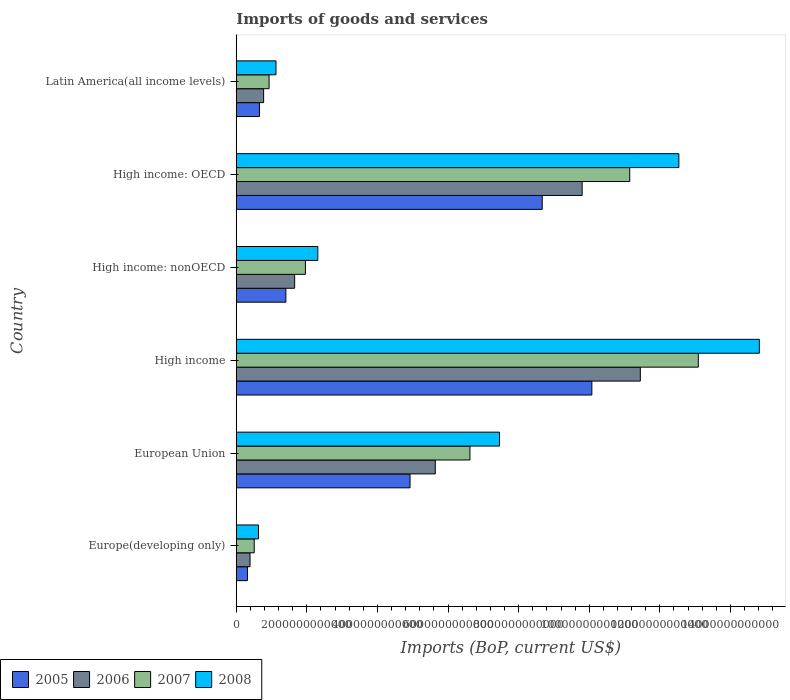How many different coloured bars are there?
Ensure brevity in your answer.  4. How many groups of bars are there?
Keep it short and to the point. 6. Are the number of bars on each tick of the Y-axis equal?
Give a very brief answer. Yes. How many bars are there on the 3rd tick from the top?
Ensure brevity in your answer.  4. What is the label of the 2nd group of bars from the top?
Provide a short and direct response. High income: OECD. In how many cases, is the number of bars for a given country not equal to the number of legend labels?
Offer a terse response. 0. What is the amount spent on imports in 2007 in Latin America(all income levels)?
Offer a terse response. 9.30e+11. Across all countries, what is the maximum amount spent on imports in 2007?
Your answer should be compact. 1.31e+13. Across all countries, what is the minimum amount spent on imports in 2008?
Offer a terse response. 6.31e+11. In which country was the amount spent on imports in 2007 minimum?
Make the answer very short. Europe(developing only). What is the total amount spent on imports in 2005 in the graph?
Give a very brief answer. 2.60e+13. What is the difference between the amount spent on imports in 2005 in Europe(developing only) and that in High income: OECD?
Offer a very short reply. -8.35e+12. What is the difference between the amount spent on imports in 2007 in High income and the amount spent on imports in 2008 in High income: nonOECD?
Provide a succinct answer. 1.08e+13. What is the average amount spent on imports in 2006 per country?
Ensure brevity in your answer.  4.95e+12. What is the difference between the amount spent on imports in 2008 and amount spent on imports in 2005 in Latin America(all income levels)?
Your answer should be compact. 4.69e+11. In how many countries, is the amount spent on imports in 2006 greater than 13600000000000 US$?
Your answer should be compact. 0. What is the ratio of the amount spent on imports in 2005 in High income to that in Latin America(all income levels)?
Offer a very short reply. 15.33. Is the amount spent on imports in 2008 in Europe(developing only) less than that in European Union?
Offer a terse response. Yes. Is the difference between the amount spent on imports in 2008 in Europe(developing only) and High income greater than the difference between the amount spent on imports in 2005 in Europe(developing only) and High income?
Keep it short and to the point. No. What is the difference between the highest and the second highest amount spent on imports in 2006?
Your response must be concise. 1.65e+12. What is the difference between the highest and the lowest amount spent on imports in 2006?
Your answer should be compact. 1.11e+13. Is the sum of the amount spent on imports in 2007 in High income and Latin America(all income levels) greater than the maximum amount spent on imports in 2005 across all countries?
Your answer should be compact. Yes. What does the 4th bar from the bottom in High income: nonOECD represents?
Ensure brevity in your answer.  2008. Is it the case that in every country, the sum of the amount spent on imports in 2006 and amount spent on imports in 2007 is greater than the amount spent on imports in 2005?
Provide a short and direct response. Yes. How many bars are there?
Offer a very short reply. 24. How many countries are there in the graph?
Your answer should be very brief. 6. What is the difference between two consecutive major ticks on the X-axis?
Your answer should be very brief. 2.00e+12. Are the values on the major ticks of X-axis written in scientific E-notation?
Offer a very short reply. No. What is the title of the graph?
Provide a short and direct response. Imports of goods and services. What is the label or title of the X-axis?
Provide a succinct answer. Imports (BoP, current US$). What is the label or title of the Y-axis?
Keep it short and to the point. Country. What is the Imports (BoP, current US$) of 2005 in Europe(developing only)?
Give a very brief answer. 3.17e+11. What is the Imports (BoP, current US$) of 2006 in Europe(developing only)?
Ensure brevity in your answer.  3.90e+11. What is the Imports (BoP, current US$) of 2007 in Europe(developing only)?
Provide a short and direct response. 5.09e+11. What is the Imports (BoP, current US$) in 2008 in Europe(developing only)?
Offer a very short reply. 6.31e+11. What is the Imports (BoP, current US$) of 2005 in European Union?
Ensure brevity in your answer.  4.92e+12. What is the Imports (BoP, current US$) in 2006 in European Union?
Provide a succinct answer. 5.64e+12. What is the Imports (BoP, current US$) in 2007 in European Union?
Provide a succinct answer. 6.62e+12. What is the Imports (BoP, current US$) in 2008 in European Union?
Ensure brevity in your answer.  7.46e+12. What is the Imports (BoP, current US$) in 2005 in High income?
Provide a succinct answer. 1.01e+13. What is the Imports (BoP, current US$) in 2006 in High income?
Your response must be concise. 1.14e+13. What is the Imports (BoP, current US$) in 2007 in High income?
Give a very brief answer. 1.31e+13. What is the Imports (BoP, current US$) of 2008 in High income?
Make the answer very short. 1.48e+13. What is the Imports (BoP, current US$) in 2005 in High income: nonOECD?
Provide a succinct answer. 1.41e+12. What is the Imports (BoP, current US$) of 2006 in High income: nonOECD?
Give a very brief answer. 1.65e+12. What is the Imports (BoP, current US$) of 2007 in High income: nonOECD?
Offer a terse response. 1.96e+12. What is the Imports (BoP, current US$) in 2008 in High income: nonOECD?
Provide a succinct answer. 2.31e+12. What is the Imports (BoP, current US$) in 2005 in High income: OECD?
Give a very brief answer. 8.67e+12. What is the Imports (BoP, current US$) in 2006 in High income: OECD?
Keep it short and to the point. 9.80e+12. What is the Imports (BoP, current US$) in 2007 in High income: OECD?
Your answer should be compact. 1.11e+13. What is the Imports (BoP, current US$) of 2008 in High income: OECD?
Your response must be concise. 1.25e+13. What is the Imports (BoP, current US$) in 2005 in Latin America(all income levels)?
Ensure brevity in your answer.  6.57e+11. What is the Imports (BoP, current US$) of 2006 in Latin America(all income levels)?
Provide a short and direct response. 7.75e+11. What is the Imports (BoP, current US$) of 2007 in Latin America(all income levels)?
Your answer should be compact. 9.30e+11. What is the Imports (BoP, current US$) in 2008 in Latin America(all income levels)?
Provide a short and direct response. 1.13e+12. Across all countries, what is the maximum Imports (BoP, current US$) of 2005?
Offer a very short reply. 1.01e+13. Across all countries, what is the maximum Imports (BoP, current US$) in 2006?
Your answer should be very brief. 1.14e+13. Across all countries, what is the maximum Imports (BoP, current US$) in 2007?
Offer a very short reply. 1.31e+13. Across all countries, what is the maximum Imports (BoP, current US$) in 2008?
Provide a short and direct response. 1.48e+13. Across all countries, what is the minimum Imports (BoP, current US$) of 2005?
Your answer should be very brief. 3.17e+11. Across all countries, what is the minimum Imports (BoP, current US$) of 2006?
Provide a short and direct response. 3.90e+11. Across all countries, what is the minimum Imports (BoP, current US$) in 2007?
Offer a very short reply. 5.09e+11. Across all countries, what is the minimum Imports (BoP, current US$) in 2008?
Provide a short and direct response. 6.31e+11. What is the total Imports (BoP, current US$) of 2005 in the graph?
Your answer should be very brief. 2.60e+13. What is the total Imports (BoP, current US$) in 2006 in the graph?
Keep it short and to the point. 2.97e+13. What is the total Imports (BoP, current US$) of 2007 in the graph?
Make the answer very short. 3.43e+13. What is the total Imports (BoP, current US$) in 2008 in the graph?
Give a very brief answer. 3.89e+13. What is the difference between the Imports (BoP, current US$) in 2005 in Europe(developing only) and that in European Union?
Your response must be concise. -4.61e+12. What is the difference between the Imports (BoP, current US$) in 2006 in Europe(developing only) and that in European Union?
Offer a terse response. -5.25e+12. What is the difference between the Imports (BoP, current US$) of 2007 in Europe(developing only) and that in European Union?
Provide a short and direct response. -6.11e+12. What is the difference between the Imports (BoP, current US$) in 2008 in Europe(developing only) and that in European Union?
Your answer should be very brief. -6.83e+12. What is the difference between the Imports (BoP, current US$) in 2005 in Europe(developing only) and that in High income?
Provide a succinct answer. -9.76e+12. What is the difference between the Imports (BoP, current US$) of 2006 in Europe(developing only) and that in High income?
Your answer should be compact. -1.11e+13. What is the difference between the Imports (BoP, current US$) in 2007 in Europe(developing only) and that in High income?
Provide a short and direct response. -1.26e+13. What is the difference between the Imports (BoP, current US$) in 2008 in Europe(developing only) and that in High income?
Your answer should be very brief. -1.42e+13. What is the difference between the Imports (BoP, current US$) in 2005 in Europe(developing only) and that in High income: nonOECD?
Offer a very short reply. -1.09e+12. What is the difference between the Imports (BoP, current US$) of 2006 in Europe(developing only) and that in High income: nonOECD?
Your answer should be very brief. -1.26e+12. What is the difference between the Imports (BoP, current US$) of 2007 in Europe(developing only) and that in High income: nonOECD?
Give a very brief answer. -1.45e+12. What is the difference between the Imports (BoP, current US$) of 2008 in Europe(developing only) and that in High income: nonOECD?
Your answer should be compact. -1.68e+12. What is the difference between the Imports (BoP, current US$) of 2005 in Europe(developing only) and that in High income: OECD?
Ensure brevity in your answer.  -8.35e+12. What is the difference between the Imports (BoP, current US$) in 2006 in Europe(developing only) and that in High income: OECD?
Keep it short and to the point. -9.41e+12. What is the difference between the Imports (BoP, current US$) in 2007 in Europe(developing only) and that in High income: OECD?
Offer a very short reply. -1.06e+13. What is the difference between the Imports (BoP, current US$) in 2008 in Europe(developing only) and that in High income: OECD?
Offer a very short reply. -1.19e+13. What is the difference between the Imports (BoP, current US$) of 2005 in Europe(developing only) and that in Latin America(all income levels)?
Offer a very short reply. -3.40e+11. What is the difference between the Imports (BoP, current US$) of 2006 in Europe(developing only) and that in Latin America(all income levels)?
Offer a terse response. -3.85e+11. What is the difference between the Imports (BoP, current US$) in 2007 in Europe(developing only) and that in Latin America(all income levels)?
Make the answer very short. -4.21e+11. What is the difference between the Imports (BoP, current US$) of 2008 in Europe(developing only) and that in Latin America(all income levels)?
Make the answer very short. -4.95e+11. What is the difference between the Imports (BoP, current US$) of 2005 in European Union and that in High income?
Your response must be concise. -5.15e+12. What is the difference between the Imports (BoP, current US$) in 2006 in European Union and that in High income?
Ensure brevity in your answer.  -5.81e+12. What is the difference between the Imports (BoP, current US$) of 2007 in European Union and that in High income?
Make the answer very short. -6.47e+12. What is the difference between the Imports (BoP, current US$) in 2008 in European Union and that in High income?
Provide a succinct answer. -7.36e+12. What is the difference between the Imports (BoP, current US$) in 2005 in European Union and that in High income: nonOECD?
Your response must be concise. 3.52e+12. What is the difference between the Imports (BoP, current US$) of 2006 in European Union and that in High income: nonOECD?
Your answer should be very brief. 3.98e+12. What is the difference between the Imports (BoP, current US$) in 2007 in European Union and that in High income: nonOECD?
Offer a terse response. 4.66e+12. What is the difference between the Imports (BoP, current US$) in 2008 in European Union and that in High income: nonOECD?
Your response must be concise. 5.15e+12. What is the difference between the Imports (BoP, current US$) of 2005 in European Union and that in High income: OECD?
Make the answer very short. -3.74e+12. What is the difference between the Imports (BoP, current US$) of 2006 in European Union and that in High income: OECD?
Give a very brief answer. -4.16e+12. What is the difference between the Imports (BoP, current US$) of 2007 in European Union and that in High income: OECD?
Offer a terse response. -4.53e+12. What is the difference between the Imports (BoP, current US$) of 2008 in European Union and that in High income: OECD?
Your answer should be very brief. -5.08e+12. What is the difference between the Imports (BoP, current US$) of 2005 in European Union and that in Latin America(all income levels)?
Provide a short and direct response. 4.27e+12. What is the difference between the Imports (BoP, current US$) in 2006 in European Union and that in Latin America(all income levels)?
Provide a succinct answer. 4.86e+12. What is the difference between the Imports (BoP, current US$) in 2007 in European Union and that in Latin America(all income levels)?
Offer a terse response. 5.69e+12. What is the difference between the Imports (BoP, current US$) in 2008 in European Union and that in Latin America(all income levels)?
Make the answer very short. 6.33e+12. What is the difference between the Imports (BoP, current US$) in 2005 in High income and that in High income: nonOECD?
Your answer should be very brief. 8.67e+12. What is the difference between the Imports (BoP, current US$) in 2006 in High income and that in High income: nonOECD?
Your answer should be compact. 9.79e+12. What is the difference between the Imports (BoP, current US$) of 2007 in High income and that in High income: nonOECD?
Provide a succinct answer. 1.11e+13. What is the difference between the Imports (BoP, current US$) of 2008 in High income and that in High income: nonOECD?
Give a very brief answer. 1.25e+13. What is the difference between the Imports (BoP, current US$) in 2005 in High income and that in High income: OECD?
Keep it short and to the point. 1.41e+12. What is the difference between the Imports (BoP, current US$) in 2006 in High income and that in High income: OECD?
Make the answer very short. 1.65e+12. What is the difference between the Imports (BoP, current US$) of 2007 in High income and that in High income: OECD?
Your answer should be very brief. 1.94e+12. What is the difference between the Imports (BoP, current US$) of 2008 in High income and that in High income: OECD?
Ensure brevity in your answer.  2.28e+12. What is the difference between the Imports (BoP, current US$) of 2005 in High income and that in Latin America(all income levels)?
Keep it short and to the point. 9.42e+12. What is the difference between the Imports (BoP, current US$) in 2006 in High income and that in Latin America(all income levels)?
Offer a very short reply. 1.07e+13. What is the difference between the Imports (BoP, current US$) in 2007 in High income and that in Latin America(all income levels)?
Keep it short and to the point. 1.22e+13. What is the difference between the Imports (BoP, current US$) of 2008 in High income and that in Latin America(all income levels)?
Provide a short and direct response. 1.37e+13. What is the difference between the Imports (BoP, current US$) of 2005 in High income: nonOECD and that in High income: OECD?
Give a very brief answer. -7.26e+12. What is the difference between the Imports (BoP, current US$) in 2006 in High income: nonOECD and that in High income: OECD?
Your answer should be compact. -8.14e+12. What is the difference between the Imports (BoP, current US$) of 2007 in High income: nonOECD and that in High income: OECD?
Give a very brief answer. -9.19e+12. What is the difference between the Imports (BoP, current US$) in 2008 in High income: nonOECD and that in High income: OECD?
Offer a terse response. -1.02e+13. What is the difference between the Imports (BoP, current US$) of 2005 in High income: nonOECD and that in Latin America(all income levels)?
Your answer should be very brief. 7.48e+11. What is the difference between the Imports (BoP, current US$) of 2006 in High income: nonOECD and that in Latin America(all income levels)?
Keep it short and to the point. 8.79e+11. What is the difference between the Imports (BoP, current US$) in 2007 in High income: nonOECD and that in Latin America(all income levels)?
Offer a very short reply. 1.03e+12. What is the difference between the Imports (BoP, current US$) of 2008 in High income: nonOECD and that in Latin America(all income levels)?
Your answer should be very brief. 1.18e+12. What is the difference between the Imports (BoP, current US$) of 2005 in High income: OECD and that in Latin America(all income levels)?
Offer a terse response. 8.01e+12. What is the difference between the Imports (BoP, current US$) in 2006 in High income: OECD and that in Latin America(all income levels)?
Provide a short and direct response. 9.02e+12. What is the difference between the Imports (BoP, current US$) in 2007 in High income: OECD and that in Latin America(all income levels)?
Make the answer very short. 1.02e+13. What is the difference between the Imports (BoP, current US$) in 2008 in High income: OECD and that in Latin America(all income levels)?
Offer a terse response. 1.14e+13. What is the difference between the Imports (BoP, current US$) in 2005 in Europe(developing only) and the Imports (BoP, current US$) in 2006 in European Union?
Your answer should be compact. -5.32e+12. What is the difference between the Imports (BoP, current US$) in 2005 in Europe(developing only) and the Imports (BoP, current US$) in 2007 in European Union?
Offer a very short reply. -6.30e+12. What is the difference between the Imports (BoP, current US$) of 2005 in Europe(developing only) and the Imports (BoP, current US$) of 2008 in European Union?
Offer a terse response. -7.14e+12. What is the difference between the Imports (BoP, current US$) of 2006 in Europe(developing only) and the Imports (BoP, current US$) of 2007 in European Union?
Provide a short and direct response. -6.23e+12. What is the difference between the Imports (BoP, current US$) in 2006 in Europe(developing only) and the Imports (BoP, current US$) in 2008 in European Union?
Make the answer very short. -7.07e+12. What is the difference between the Imports (BoP, current US$) of 2007 in Europe(developing only) and the Imports (BoP, current US$) of 2008 in European Union?
Your answer should be compact. -6.95e+12. What is the difference between the Imports (BoP, current US$) in 2005 in Europe(developing only) and the Imports (BoP, current US$) in 2006 in High income?
Your answer should be compact. -1.11e+13. What is the difference between the Imports (BoP, current US$) in 2005 in Europe(developing only) and the Imports (BoP, current US$) in 2007 in High income?
Provide a short and direct response. -1.28e+13. What is the difference between the Imports (BoP, current US$) in 2005 in Europe(developing only) and the Imports (BoP, current US$) in 2008 in High income?
Provide a short and direct response. -1.45e+13. What is the difference between the Imports (BoP, current US$) of 2006 in Europe(developing only) and the Imports (BoP, current US$) of 2007 in High income?
Your answer should be very brief. -1.27e+13. What is the difference between the Imports (BoP, current US$) of 2006 in Europe(developing only) and the Imports (BoP, current US$) of 2008 in High income?
Your answer should be compact. -1.44e+13. What is the difference between the Imports (BoP, current US$) in 2007 in Europe(developing only) and the Imports (BoP, current US$) in 2008 in High income?
Ensure brevity in your answer.  -1.43e+13. What is the difference between the Imports (BoP, current US$) in 2005 in Europe(developing only) and the Imports (BoP, current US$) in 2006 in High income: nonOECD?
Offer a terse response. -1.34e+12. What is the difference between the Imports (BoP, current US$) of 2005 in Europe(developing only) and the Imports (BoP, current US$) of 2007 in High income: nonOECD?
Offer a very short reply. -1.64e+12. What is the difference between the Imports (BoP, current US$) of 2005 in Europe(developing only) and the Imports (BoP, current US$) of 2008 in High income: nonOECD?
Give a very brief answer. -1.99e+12. What is the difference between the Imports (BoP, current US$) of 2006 in Europe(developing only) and the Imports (BoP, current US$) of 2007 in High income: nonOECD?
Offer a terse response. -1.57e+12. What is the difference between the Imports (BoP, current US$) of 2006 in Europe(developing only) and the Imports (BoP, current US$) of 2008 in High income: nonOECD?
Provide a succinct answer. -1.92e+12. What is the difference between the Imports (BoP, current US$) of 2007 in Europe(developing only) and the Imports (BoP, current US$) of 2008 in High income: nonOECD?
Your response must be concise. -1.80e+12. What is the difference between the Imports (BoP, current US$) in 2005 in Europe(developing only) and the Imports (BoP, current US$) in 2006 in High income: OECD?
Your answer should be compact. -9.48e+12. What is the difference between the Imports (BoP, current US$) in 2005 in Europe(developing only) and the Imports (BoP, current US$) in 2007 in High income: OECD?
Offer a terse response. -1.08e+13. What is the difference between the Imports (BoP, current US$) in 2005 in Europe(developing only) and the Imports (BoP, current US$) in 2008 in High income: OECD?
Provide a short and direct response. -1.22e+13. What is the difference between the Imports (BoP, current US$) in 2006 in Europe(developing only) and the Imports (BoP, current US$) in 2007 in High income: OECD?
Your response must be concise. -1.08e+13. What is the difference between the Imports (BoP, current US$) in 2006 in Europe(developing only) and the Imports (BoP, current US$) in 2008 in High income: OECD?
Give a very brief answer. -1.21e+13. What is the difference between the Imports (BoP, current US$) of 2007 in Europe(developing only) and the Imports (BoP, current US$) of 2008 in High income: OECD?
Your response must be concise. -1.20e+13. What is the difference between the Imports (BoP, current US$) in 2005 in Europe(developing only) and the Imports (BoP, current US$) in 2006 in Latin America(all income levels)?
Your answer should be very brief. -4.58e+11. What is the difference between the Imports (BoP, current US$) of 2005 in Europe(developing only) and the Imports (BoP, current US$) of 2007 in Latin America(all income levels)?
Offer a very short reply. -6.13e+11. What is the difference between the Imports (BoP, current US$) of 2005 in Europe(developing only) and the Imports (BoP, current US$) of 2008 in Latin America(all income levels)?
Provide a succinct answer. -8.09e+11. What is the difference between the Imports (BoP, current US$) in 2006 in Europe(developing only) and the Imports (BoP, current US$) in 2007 in Latin America(all income levels)?
Your answer should be very brief. -5.40e+11. What is the difference between the Imports (BoP, current US$) in 2006 in Europe(developing only) and the Imports (BoP, current US$) in 2008 in Latin America(all income levels)?
Your answer should be very brief. -7.36e+11. What is the difference between the Imports (BoP, current US$) in 2007 in Europe(developing only) and the Imports (BoP, current US$) in 2008 in Latin America(all income levels)?
Your answer should be very brief. -6.17e+11. What is the difference between the Imports (BoP, current US$) of 2005 in European Union and the Imports (BoP, current US$) of 2006 in High income?
Your answer should be compact. -6.52e+12. What is the difference between the Imports (BoP, current US$) in 2005 in European Union and the Imports (BoP, current US$) in 2007 in High income?
Offer a very short reply. -8.17e+12. What is the difference between the Imports (BoP, current US$) of 2005 in European Union and the Imports (BoP, current US$) of 2008 in High income?
Give a very brief answer. -9.89e+12. What is the difference between the Imports (BoP, current US$) in 2006 in European Union and the Imports (BoP, current US$) in 2007 in High income?
Make the answer very short. -7.45e+12. What is the difference between the Imports (BoP, current US$) in 2006 in European Union and the Imports (BoP, current US$) in 2008 in High income?
Provide a short and direct response. -9.18e+12. What is the difference between the Imports (BoP, current US$) of 2007 in European Union and the Imports (BoP, current US$) of 2008 in High income?
Provide a succinct answer. -8.20e+12. What is the difference between the Imports (BoP, current US$) of 2005 in European Union and the Imports (BoP, current US$) of 2006 in High income: nonOECD?
Give a very brief answer. 3.27e+12. What is the difference between the Imports (BoP, current US$) in 2005 in European Union and the Imports (BoP, current US$) in 2007 in High income: nonOECD?
Your response must be concise. 2.96e+12. What is the difference between the Imports (BoP, current US$) in 2005 in European Union and the Imports (BoP, current US$) in 2008 in High income: nonOECD?
Your answer should be compact. 2.61e+12. What is the difference between the Imports (BoP, current US$) in 2006 in European Union and the Imports (BoP, current US$) in 2007 in High income: nonOECD?
Your answer should be compact. 3.68e+12. What is the difference between the Imports (BoP, current US$) in 2006 in European Union and the Imports (BoP, current US$) in 2008 in High income: nonOECD?
Make the answer very short. 3.33e+12. What is the difference between the Imports (BoP, current US$) of 2007 in European Union and the Imports (BoP, current US$) of 2008 in High income: nonOECD?
Make the answer very short. 4.31e+12. What is the difference between the Imports (BoP, current US$) in 2005 in European Union and the Imports (BoP, current US$) in 2006 in High income: OECD?
Your answer should be very brief. -4.88e+12. What is the difference between the Imports (BoP, current US$) in 2005 in European Union and the Imports (BoP, current US$) in 2007 in High income: OECD?
Give a very brief answer. -6.22e+12. What is the difference between the Imports (BoP, current US$) in 2005 in European Union and the Imports (BoP, current US$) in 2008 in High income: OECD?
Make the answer very short. -7.61e+12. What is the difference between the Imports (BoP, current US$) in 2006 in European Union and the Imports (BoP, current US$) in 2007 in High income: OECD?
Provide a short and direct response. -5.51e+12. What is the difference between the Imports (BoP, current US$) in 2006 in European Union and the Imports (BoP, current US$) in 2008 in High income: OECD?
Provide a short and direct response. -6.90e+12. What is the difference between the Imports (BoP, current US$) in 2007 in European Union and the Imports (BoP, current US$) in 2008 in High income: OECD?
Ensure brevity in your answer.  -5.92e+12. What is the difference between the Imports (BoP, current US$) in 2005 in European Union and the Imports (BoP, current US$) in 2006 in Latin America(all income levels)?
Provide a short and direct response. 4.15e+12. What is the difference between the Imports (BoP, current US$) of 2005 in European Union and the Imports (BoP, current US$) of 2007 in Latin America(all income levels)?
Your response must be concise. 3.99e+12. What is the difference between the Imports (BoP, current US$) in 2005 in European Union and the Imports (BoP, current US$) in 2008 in Latin America(all income levels)?
Keep it short and to the point. 3.80e+12. What is the difference between the Imports (BoP, current US$) in 2006 in European Union and the Imports (BoP, current US$) in 2007 in Latin America(all income levels)?
Provide a short and direct response. 4.71e+12. What is the difference between the Imports (BoP, current US$) in 2006 in European Union and the Imports (BoP, current US$) in 2008 in Latin America(all income levels)?
Offer a terse response. 4.51e+12. What is the difference between the Imports (BoP, current US$) of 2007 in European Union and the Imports (BoP, current US$) of 2008 in Latin America(all income levels)?
Give a very brief answer. 5.49e+12. What is the difference between the Imports (BoP, current US$) in 2005 in High income and the Imports (BoP, current US$) in 2006 in High income: nonOECD?
Provide a succinct answer. 8.42e+12. What is the difference between the Imports (BoP, current US$) of 2005 in High income and the Imports (BoP, current US$) of 2007 in High income: nonOECD?
Ensure brevity in your answer.  8.11e+12. What is the difference between the Imports (BoP, current US$) of 2005 in High income and the Imports (BoP, current US$) of 2008 in High income: nonOECD?
Give a very brief answer. 7.76e+12. What is the difference between the Imports (BoP, current US$) of 2006 in High income and the Imports (BoP, current US$) of 2007 in High income: nonOECD?
Offer a very short reply. 9.49e+12. What is the difference between the Imports (BoP, current US$) of 2006 in High income and the Imports (BoP, current US$) of 2008 in High income: nonOECD?
Your answer should be compact. 9.14e+12. What is the difference between the Imports (BoP, current US$) in 2007 in High income and the Imports (BoP, current US$) in 2008 in High income: nonOECD?
Your response must be concise. 1.08e+13. What is the difference between the Imports (BoP, current US$) of 2005 in High income and the Imports (BoP, current US$) of 2006 in High income: OECD?
Provide a short and direct response. 2.75e+11. What is the difference between the Imports (BoP, current US$) in 2005 in High income and the Imports (BoP, current US$) in 2007 in High income: OECD?
Offer a terse response. -1.07e+12. What is the difference between the Imports (BoP, current US$) of 2005 in High income and the Imports (BoP, current US$) of 2008 in High income: OECD?
Keep it short and to the point. -2.46e+12. What is the difference between the Imports (BoP, current US$) in 2006 in High income and the Imports (BoP, current US$) in 2007 in High income: OECD?
Provide a succinct answer. 3.00e+11. What is the difference between the Imports (BoP, current US$) in 2006 in High income and the Imports (BoP, current US$) in 2008 in High income: OECD?
Offer a terse response. -1.09e+12. What is the difference between the Imports (BoP, current US$) of 2007 in High income and the Imports (BoP, current US$) of 2008 in High income: OECD?
Provide a short and direct response. 5.51e+11. What is the difference between the Imports (BoP, current US$) of 2005 in High income and the Imports (BoP, current US$) of 2006 in Latin America(all income levels)?
Provide a succinct answer. 9.30e+12. What is the difference between the Imports (BoP, current US$) in 2005 in High income and the Imports (BoP, current US$) in 2007 in Latin America(all income levels)?
Provide a short and direct response. 9.14e+12. What is the difference between the Imports (BoP, current US$) in 2005 in High income and the Imports (BoP, current US$) in 2008 in Latin America(all income levels)?
Your answer should be compact. 8.95e+12. What is the difference between the Imports (BoP, current US$) of 2006 in High income and the Imports (BoP, current US$) of 2007 in Latin America(all income levels)?
Offer a terse response. 1.05e+13. What is the difference between the Imports (BoP, current US$) in 2006 in High income and the Imports (BoP, current US$) in 2008 in Latin America(all income levels)?
Ensure brevity in your answer.  1.03e+13. What is the difference between the Imports (BoP, current US$) of 2007 in High income and the Imports (BoP, current US$) of 2008 in Latin America(all income levels)?
Offer a terse response. 1.20e+13. What is the difference between the Imports (BoP, current US$) in 2005 in High income: nonOECD and the Imports (BoP, current US$) in 2006 in High income: OECD?
Ensure brevity in your answer.  -8.39e+12. What is the difference between the Imports (BoP, current US$) in 2005 in High income: nonOECD and the Imports (BoP, current US$) in 2007 in High income: OECD?
Make the answer very short. -9.74e+12. What is the difference between the Imports (BoP, current US$) of 2005 in High income: nonOECD and the Imports (BoP, current US$) of 2008 in High income: OECD?
Offer a terse response. -1.11e+13. What is the difference between the Imports (BoP, current US$) in 2006 in High income: nonOECD and the Imports (BoP, current US$) in 2007 in High income: OECD?
Provide a succinct answer. -9.49e+12. What is the difference between the Imports (BoP, current US$) of 2006 in High income: nonOECD and the Imports (BoP, current US$) of 2008 in High income: OECD?
Provide a succinct answer. -1.09e+13. What is the difference between the Imports (BoP, current US$) in 2007 in High income: nonOECD and the Imports (BoP, current US$) in 2008 in High income: OECD?
Give a very brief answer. -1.06e+13. What is the difference between the Imports (BoP, current US$) in 2005 in High income: nonOECD and the Imports (BoP, current US$) in 2006 in Latin America(all income levels)?
Give a very brief answer. 6.30e+11. What is the difference between the Imports (BoP, current US$) of 2005 in High income: nonOECD and the Imports (BoP, current US$) of 2007 in Latin America(all income levels)?
Provide a short and direct response. 4.76e+11. What is the difference between the Imports (BoP, current US$) in 2005 in High income: nonOECD and the Imports (BoP, current US$) in 2008 in Latin America(all income levels)?
Give a very brief answer. 2.79e+11. What is the difference between the Imports (BoP, current US$) in 2006 in High income: nonOECD and the Imports (BoP, current US$) in 2007 in Latin America(all income levels)?
Your answer should be very brief. 7.25e+11. What is the difference between the Imports (BoP, current US$) of 2006 in High income: nonOECD and the Imports (BoP, current US$) of 2008 in Latin America(all income levels)?
Ensure brevity in your answer.  5.28e+11. What is the difference between the Imports (BoP, current US$) of 2007 in High income: nonOECD and the Imports (BoP, current US$) of 2008 in Latin America(all income levels)?
Your answer should be compact. 8.33e+11. What is the difference between the Imports (BoP, current US$) of 2005 in High income: OECD and the Imports (BoP, current US$) of 2006 in Latin America(all income levels)?
Provide a succinct answer. 7.89e+12. What is the difference between the Imports (BoP, current US$) of 2005 in High income: OECD and the Imports (BoP, current US$) of 2007 in Latin America(all income levels)?
Your answer should be compact. 7.74e+12. What is the difference between the Imports (BoP, current US$) in 2005 in High income: OECD and the Imports (BoP, current US$) in 2008 in Latin America(all income levels)?
Give a very brief answer. 7.54e+12. What is the difference between the Imports (BoP, current US$) of 2006 in High income: OECD and the Imports (BoP, current US$) of 2007 in Latin America(all income levels)?
Give a very brief answer. 8.87e+12. What is the difference between the Imports (BoP, current US$) in 2006 in High income: OECD and the Imports (BoP, current US$) in 2008 in Latin America(all income levels)?
Keep it short and to the point. 8.67e+12. What is the difference between the Imports (BoP, current US$) of 2007 in High income: OECD and the Imports (BoP, current US$) of 2008 in Latin America(all income levels)?
Ensure brevity in your answer.  1.00e+13. What is the average Imports (BoP, current US$) in 2005 per country?
Ensure brevity in your answer.  4.34e+12. What is the average Imports (BoP, current US$) of 2006 per country?
Give a very brief answer. 4.95e+12. What is the average Imports (BoP, current US$) of 2007 per country?
Offer a very short reply. 5.71e+12. What is the average Imports (BoP, current US$) in 2008 per country?
Provide a succinct answer. 6.48e+12. What is the difference between the Imports (BoP, current US$) of 2005 and Imports (BoP, current US$) of 2006 in Europe(developing only)?
Make the answer very short. -7.33e+1. What is the difference between the Imports (BoP, current US$) of 2005 and Imports (BoP, current US$) of 2007 in Europe(developing only)?
Offer a very short reply. -1.92e+11. What is the difference between the Imports (BoP, current US$) in 2005 and Imports (BoP, current US$) in 2008 in Europe(developing only)?
Make the answer very short. -3.14e+11. What is the difference between the Imports (BoP, current US$) in 2006 and Imports (BoP, current US$) in 2007 in Europe(developing only)?
Provide a short and direct response. -1.18e+11. What is the difference between the Imports (BoP, current US$) in 2006 and Imports (BoP, current US$) in 2008 in Europe(developing only)?
Provide a short and direct response. -2.40e+11. What is the difference between the Imports (BoP, current US$) in 2007 and Imports (BoP, current US$) in 2008 in Europe(developing only)?
Your response must be concise. -1.22e+11. What is the difference between the Imports (BoP, current US$) of 2005 and Imports (BoP, current US$) of 2006 in European Union?
Your answer should be very brief. -7.15e+11. What is the difference between the Imports (BoP, current US$) in 2005 and Imports (BoP, current US$) in 2007 in European Union?
Provide a short and direct response. -1.70e+12. What is the difference between the Imports (BoP, current US$) of 2005 and Imports (BoP, current US$) of 2008 in European Union?
Your response must be concise. -2.53e+12. What is the difference between the Imports (BoP, current US$) of 2006 and Imports (BoP, current US$) of 2007 in European Union?
Offer a terse response. -9.82e+11. What is the difference between the Imports (BoP, current US$) in 2006 and Imports (BoP, current US$) in 2008 in European Union?
Ensure brevity in your answer.  -1.82e+12. What is the difference between the Imports (BoP, current US$) of 2007 and Imports (BoP, current US$) of 2008 in European Union?
Your response must be concise. -8.37e+11. What is the difference between the Imports (BoP, current US$) in 2005 and Imports (BoP, current US$) in 2006 in High income?
Give a very brief answer. -1.37e+12. What is the difference between the Imports (BoP, current US$) in 2005 and Imports (BoP, current US$) in 2007 in High income?
Your answer should be compact. -3.02e+12. What is the difference between the Imports (BoP, current US$) in 2005 and Imports (BoP, current US$) in 2008 in High income?
Give a very brief answer. -4.74e+12. What is the difference between the Imports (BoP, current US$) of 2006 and Imports (BoP, current US$) of 2007 in High income?
Offer a terse response. -1.64e+12. What is the difference between the Imports (BoP, current US$) of 2006 and Imports (BoP, current US$) of 2008 in High income?
Your answer should be compact. -3.37e+12. What is the difference between the Imports (BoP, current US$) in 2007 and Imports (BoP, current US$) in 2008 in High income?
Make the answer very short. -1.73e+12. What is the difference between the Imports (BoP, current US$) in 2005 and Imports (BoP, current US$) in 2006 in High income: nonOECD?
Your response must be concise. -2.49e+11. What is the difference between the Imports (BoP, current US$) in 2005 and Imports (BoP, current US$) in 2007 in High income: nonOECD?
Keep it short and to the point. -5.53e+11. What is the difference between the Imports (BoP, current US$) in 2005 and Imports (BoP, current US$) in 2008 in High income: nonOECD?
Offer a very short reply. -9.05e+11. What is the difference between the Imports (BoP, current US$) of 2006 and Imports (BoP, current US$) of 2007 in High income: nonOECD?
Keep it short and to the point. -3.04e+11. What is the difference between the Imports (BoP, current US$) in 2006 and Imports (BoP, current US$) in 2008 in High income: nonOECD?
Make the answer very short. -6.56e+11. What is the difference between the Imports (BoP, current US$) of 2007 and Imports (BoP, current US$) of 2008 in High income: nonOECD?
Your answer should be very brief. -3.51e+11. What is the difference between the Imports (BoP, current US$) in 2005 and Imports (BoP, current US$) in 2006 in High income: OECD?
Keep it short and to the point. -1.13e+12. What is the difference between the Imports (BoP, current US$) in 2005 and Imports (BoP, current US$) in 2007 in High income: OECD?
Provide a succinct answer. -2.48e+12. What is the difference between the Imports (BoP, current US$) of 2005 and Imports (BoP, current US$) of 2008 in High income: OECD?
Offer a terse response. -3.87e+12. What is the difference between the Imports (BoP, current US$) of 2006 and Imports (BoP, current US$) of 2007 in High income: OECD?
Provide a succinct answer. -1.35e+12. What is the difference between the Imports (BoP, current US$) in 2006 and Imports (BoP, current US$) in 2008 in High income: OECD?
Give a very brief answer. -2.74e+12. What is the difference between the Imports (BoP, current US$) in 2007 and Imports (BoP, current US$) in 2008 in High income: OECD?
Provide a succinct answer. -1.39e+12. What is the difference between the Imports (BoP, current US$) of 2005 and Imports (BoP, current US$) of 2006 in Latin America(all income levels)?
Your answer should be very brief. -1.18e+11. What is the difference between the Imports (BoP, current US$) of 2005 and Imports (BoP, current US$) of 2007 in Latin America(all income levels)?
Keep it short and to the point. -2.72e+11. What is the difference between the Imports (BoP, current US$) in 2005 and Imports (BoP, current US$) in 2008 in Latin America(all income levels)?
Offer a very short reply. -4.69e+11. What is the difference between the Imports (BoP, current US$) in 2006 and Imports (BoP, current US$) in 2007 in Latin America(all income levels)?
Offer a very short reply. -1.54e+11. What is the difference between the Imports (BoP, current US$) of 2006 and Imports (BoP, current US$) of 2008 in Latin America(all income levels)?
Your response must be concise. -3.51e+11. What is the difference between the Imports (BoP, current US$) of 2007 and Imports (BoP, current US$) of 2008 in Latin America(all income levels)?
Your response must be concise. -1.96e+11. What is the ratio of the Imports (BoP, current US$) in 2005 in Europe(developing only) to that in European Union?
Offer a very short reply. 0.06. What is the ratio of the Imports (BoP, current US$) in 2006 in Europe(developing only) to that in European Union?
Your response must be concise. 0.07. What is the ratio of the Imports (BoP, current US$) of 2007 in Europe(developing only) to that in European Union?
Provide a succinct answer. 0.08. What is the ratio of the Imports (BoP, current US$) of 2008 in Europe(developing only) to that in European Union?
Ensure brevity in your answer.  0.08. What is the ratio of the Imports (BoP, current US$) of 2005 in Europe(developing only) to that in High income?
Offer a very short reply. 0.03. What is the ratio of the Imports (BoP, current US$) in 2006 in Europe(developing only) to that in High income?
Make the answer very short. 0.03. What is the ratio of the Imports (BoP, current US$) of 2007 in Europe(developing only) to that in High income?
Give a very brief answer. 0.04. What is the ratio of the Imports (BoP, current US$) of 2008 in Europe(developing only) to that in High income?
Give a very brief answer. 0.04. What is the ratio of the Imports (BoP, current US$) in 2005 in Europe(developing only) to that in High income: nonOECD?
Your response must be concise. 0.23. What is the ratio of the Imports (BoP, current US$) of 2006 in Europe(developing only) to that in High income: nonOECD?
Provide a succinct answer. 0.24. What is the ratio of the Imports (BoP, current US$) of 2007 in Europe(developing only) to that in High income: nonOECD?
Provide a short and direct response. 0.26. What is the ratio of the Imports (BoP, current US$) of 2008 in Europe(developing only) to that in High income: nonOECD?
Offer a terse response. 0.27. What is the ratio of the Imports (BoP, current US$) of 2005 in Europe(developing only) to that in High income: OECD?
Provide a short and direct response. 0.04. What is the ratio of the Imports (BoP, current US$) of 2006 in Europe(developing only) to that in High income: OECD?
Your answer should be very brief. 0.04. What is the ratio of the Imports (BoP, current US$) of 2007 in Europe(developing only) to that in High income: OECD?
Your answer should be very brief. 0.05. What is the ratio of the Imports (BoP, current US$) in 2008 in Europe(developing only) to that in High income: OECD?
Provide a short and direct response. 0.05. What is the ratio of the Imports (BoP, current US$) in 2005 in Europe(developing only) to that in Latin America(all income levels)?
Provide a succinct answer. 0.48. What is the ratio of the Imports (BoP, current US$) in 2006 in Europe(developing only) to that in Latin America(all income levels)?
Provide a succinct answer. 0.5. What is the ratio of the Imports (BoP, current US$) in 2007 in Europe(developing only) to that in Latin America(all income levels)?
Your answer should be very brief. 0.55. What is the ratio of the Imports (BoP, current US$) of 2008 in Europe(developing only) to that in Latin America(all income levels)?
Provide a succinct answer. 0.56. What is the ratio of the Imports (BoP, current US$) in 2005 in European Union to that in High income?
Provide a succinct answer. 0.49. What is the ratio of the Imports (BoP, current US$) in 2006 in European Union to that in High income?
Offer a terse response. 0.49. What is the ratio of the Imports (BoP, current US$) in 2007 in European Union to that in High income?
Give a very brief answer. 0.51. What is the ratio of the Imports (BoP, current US$) in 2008 in European Union to that in High income?
Ensure brevity in your answer.  0.5. What is the ratio of the Imports (BoP, current US$) in 2005 in European Union to that in High income: nonOECD?
Offer a terse response. 3.5. What is the ratio of the Imports (BoP, current US$) in 2006 in European Union to that in High income: nonOECD?
Offer a terse response. 3.41. What is the ratio of the Imports (BoP, current US$) in 2007 in European Union to that in High income: nonOECD?
Your answer should be very brief. 3.38. What is the ratio of the Imports (BoP, current US$) in 2008 in European Union to that in High income: nonOECD?
Offer a terse response. 3.23. What is the ratio of the Imports (BoP, current US$) of 2005 in European Union to that in High income: OECD?
Provide a succinct answer. 0.57. What is the ratio of the Imports (BoP, current US$) in 2006 in European Union to that in High income: OECD?
Keep it short and to the point. 0.58. What is the ratio of the Imports (BoP, current US$) of 2007 in European Union to that in High income: OECD?
Ensure brevity in your answer.  0.59. What is the ratio of the Imports (BoP, current US$) in 2008 in European Union to that in High income: OECD?
Make the answer very short. 0.59. What is the ratio of the Imports (BoP, current US$) of 2005 in European Union to that in Latin America(all income levels)?
Your answer should be compact. 7.49. What is the ratio of the Imports (BoP, current US$) in 2006 in European Union to that in Latin America(all income levels)?
Offer a very short reply. 7.27. What is the ratio of the Imports (BoP, current US$) in 2007 in European Union to that in Latin America(all income levels)?
Give a very brief answer. 7.12. What is the ratio of the Imports (BoP, current US$) in 2008 in European Union to that in Latin America(all income levels)?
Offer a very short reply. 6.62. What is the ratio of the Imports (BoP, current US$) of 2005 in High income to that in High income: nonOECD?
Offer a terse response. 7.17. What is the ratio of the Imports (BoP, current US$) of 2006 in High income to that in High income: nonOECD?
Provide a short and direct response. 6.92. What is the ratio of the Imports (BoP, current US$) of 2007 in High income to that in High income: nonOECD?
Offer a terse response. 6.68. What is the ratio of the Imports (BoP, current US$) of 2008 in High income to that in High income: nonOECD?
Provide a short and direct response. 6.41. What is the ratio of the Imports (BoP, current US$) in 2005 in High income to that in High income: OECD?
Keep it short and to the point. 1.16. What is the ratio of the Imports (BoP, current US$) in 2006 in High income to that in High income: OECD?
Provide a short and direct response. 1.17. What is the ratio of the Imports (BoP, current US$) of 2007 in High income to that in High income: OECD?
Provide a succinct answer. 1.17. What is the ratio of the Imports (BoP, current US$) of 2008 in High income to that in High income: OECD?
Make the answer very short. 1.18. What is the ratio of the Imports (BoP, current US$) in 2005 in High income to that in Latin America(all income levels)?
Keep it short and to the point. 15.33. What is the ratio of the Imports (BoP, current US$) of 2006 in High income to that in Latin America(all income levels)?
Ensure brevity in your answer.  14.76. What is the ratio of the Imports (BoP, current US$) of 2007 in High income to that in Latin America(all income levels)?
Ensure brevity in your answer.  14.08. What is the ratio of the Imports (BoP, current US$) of 2008 in High income to that in Latin America(all income levels)?
Give a very brief answer. 13.16. What is the ratio of the Imports (BoP, current US$) in 2005 in High income: nonOECD to that in High income: OECD?
Provide a succinct answer. 0.16. What is the ratio of the Imports (BoP, current US$) in 2006 in High income: nonOECD to that in High income: OECD?
Your answer should be compact. 0.17. What is the ratio of the Imports (BoP, current US$) in 2007 in High income: nonOECD to that in High income: OECD?
Your answer should be compact. 0.18. What is the ratio of the Imports (BoP, current US$) of 2008 in High income: nonOECD to that in High income: OECD?
Offer a terse response. 0.18. What is the ratio of the Imports (BoP, current US$) in 2005 in High income: nonOECD to that in Latin America(all income levels)?
Keep it short and to the point. 2.14. What is the ratio of the Imports (BoP, current US$) in 2006 in High income: nonOECD to that in Latin America(all income levels)?
Your response must be concise. 2.13. What is the ratio of the Imports (BoP, current US$) in 2007 in High income: nonOECD to that in Latin America(all income levels)?
Ensure brevity in your answer.  2.11. What is the ratio of the Imports (BoP, current US$) in 2008 in High income: nonOECD to that in Latin America(all income levels)?
Ensure brevity in your answer.  2.05. What is the ratio of the Imports (BoP, current US$) in 2005 in High income: OECD to that in Latin America(all income levels)?
Your response must be concise. 13.19. What is the ratio of the Imports (BoP, current US$) in 2006 in High income: OECD to that in Latin America(all income levels)?
Your answer should be very brief. 12.64. What is the ratio of the Imports (BoP, current US$) in 2007 in High income: OECD to that in Latin America(all income levels)?
Offer a terse response. 11.99. What is the ratio of the Imports (BoP, current US$) of 2008 in High income: OECD to that in Latin America(all income levels)?
Offer a very short reply. 11.13. What is the difference between the highest and the second highest Imports (BoP, current US$) of 2005?
Your answer should be very brief. 1.41e+12. What is the difference between the highest and the second highest Imports (BoP, current US$) of 2006?
Your response must be concise. 1.65e+12. What is the difference between the highest and the second highest Imports (BoP, current US$) of 2007?
Your answer should be compact. 1.94e+12. What is the difference between the highest and the second highest Imports (BoP, current US$) of 2008?
Keep it short and to the point. 2.28e+12. What is the difference between the highest and the lowest Imports (BoP, current US$) of 2005?
Keep it short and to the point. 9.76e+12. What is the difference between the highest and the lowest Imports (BoP, current US$) of 2006?
Ensure brevity in your answer.  1.11e+13. What is the difference between the highest and the lowest Imports (BoP, current US$) in 2007?
Make the answer very short. 1.26e+13. What is the difference between the highest and the lowest Imports (BoP, current US$) of 2008?
Provide a succinct answer. 1.42e+13. 